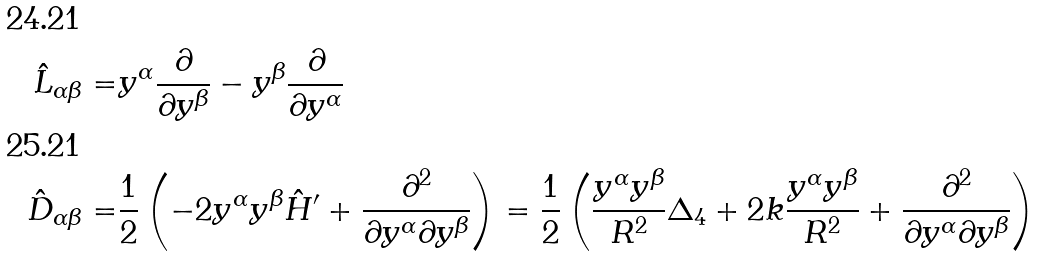Convert formula to latex. <formula><loc_0><loc_0><loc_500><loc_500>\hat { L } _ { \alpha \beta } = & y ^ { \alpha } \frac { \partial } { \partial y ^ { \beta } } - y ^ { \beta } \frac { \partial } { \partial y ^ { \alpha } } \\ \hat { D } _ { \alpha \beta } = & \frac { 1 } { 2 } \left ( - 2 y ^ { \alpha } y ^ { \beta } \hat { H } ^ { \prime } + \frac { \partial ^ { 2 } } { \partial y ^ { \alpha } \partial y ^ { \beta } } \right ) = \frac { 1 } { 2 } \left ( \frac { y ^ { \alpha } y ^ { \beta } } { R ^ { 2 } } \Delta _ { 4 } + 2 k \frac { y ^ { \alpha } y ^ { \beta } } { R ^ { 2 } } + \frac { \partial ^ { 2 } } { \partial y ^ { \alpha } \partial y ^ { \beta } } \right )</formula> 